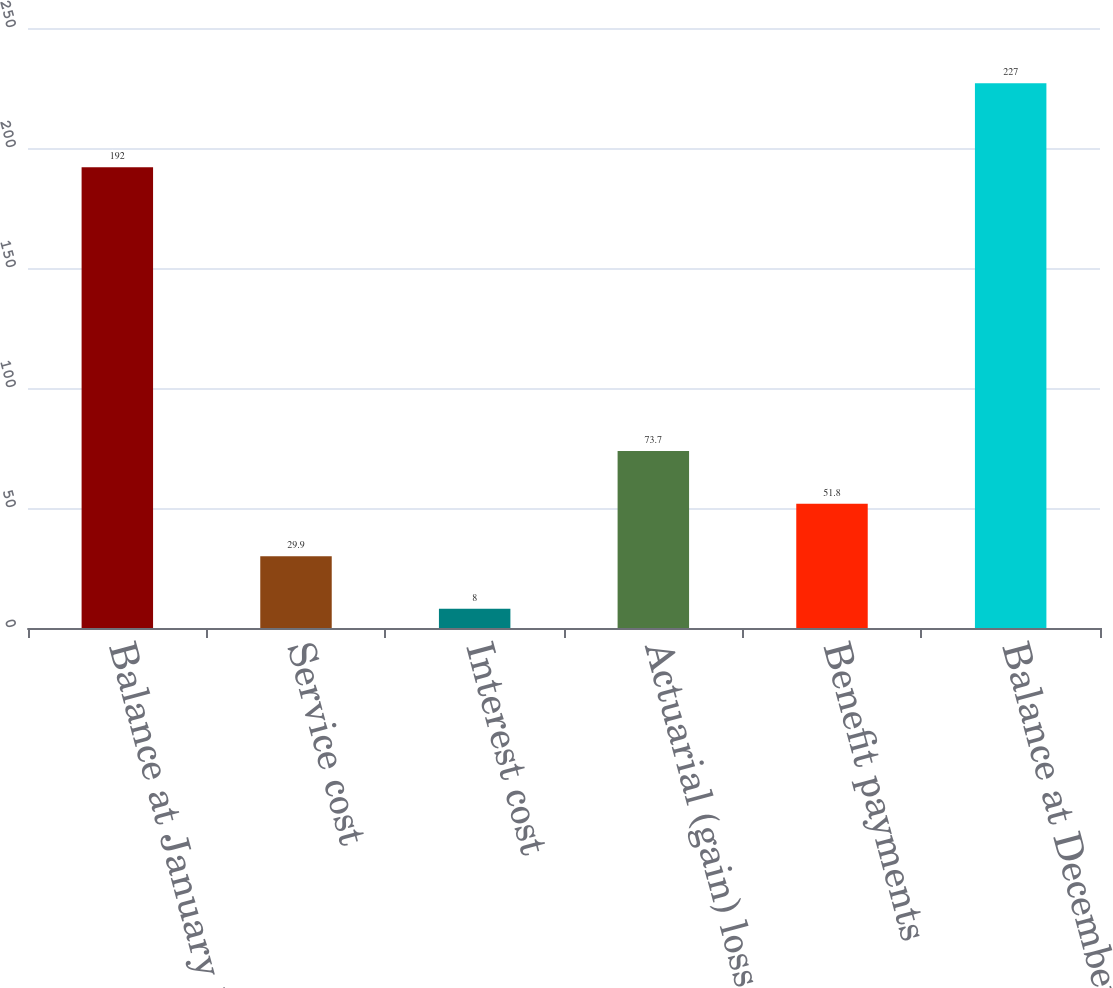Convert chart. <chart><loc_0><loc_0><loc_500><loc_500><bar_chart><fcel>Balance at January 1<fcel>Service cost<fcel>Interest cost<fcel>Actuarial (gain) loss<fcel>Benefit payments<fcel>Balance at December 31<nl><fcel>192<fcel>29.9<fcel>8<fcel>73.7<fcel>51.8<fcel>227<nl></chart> 